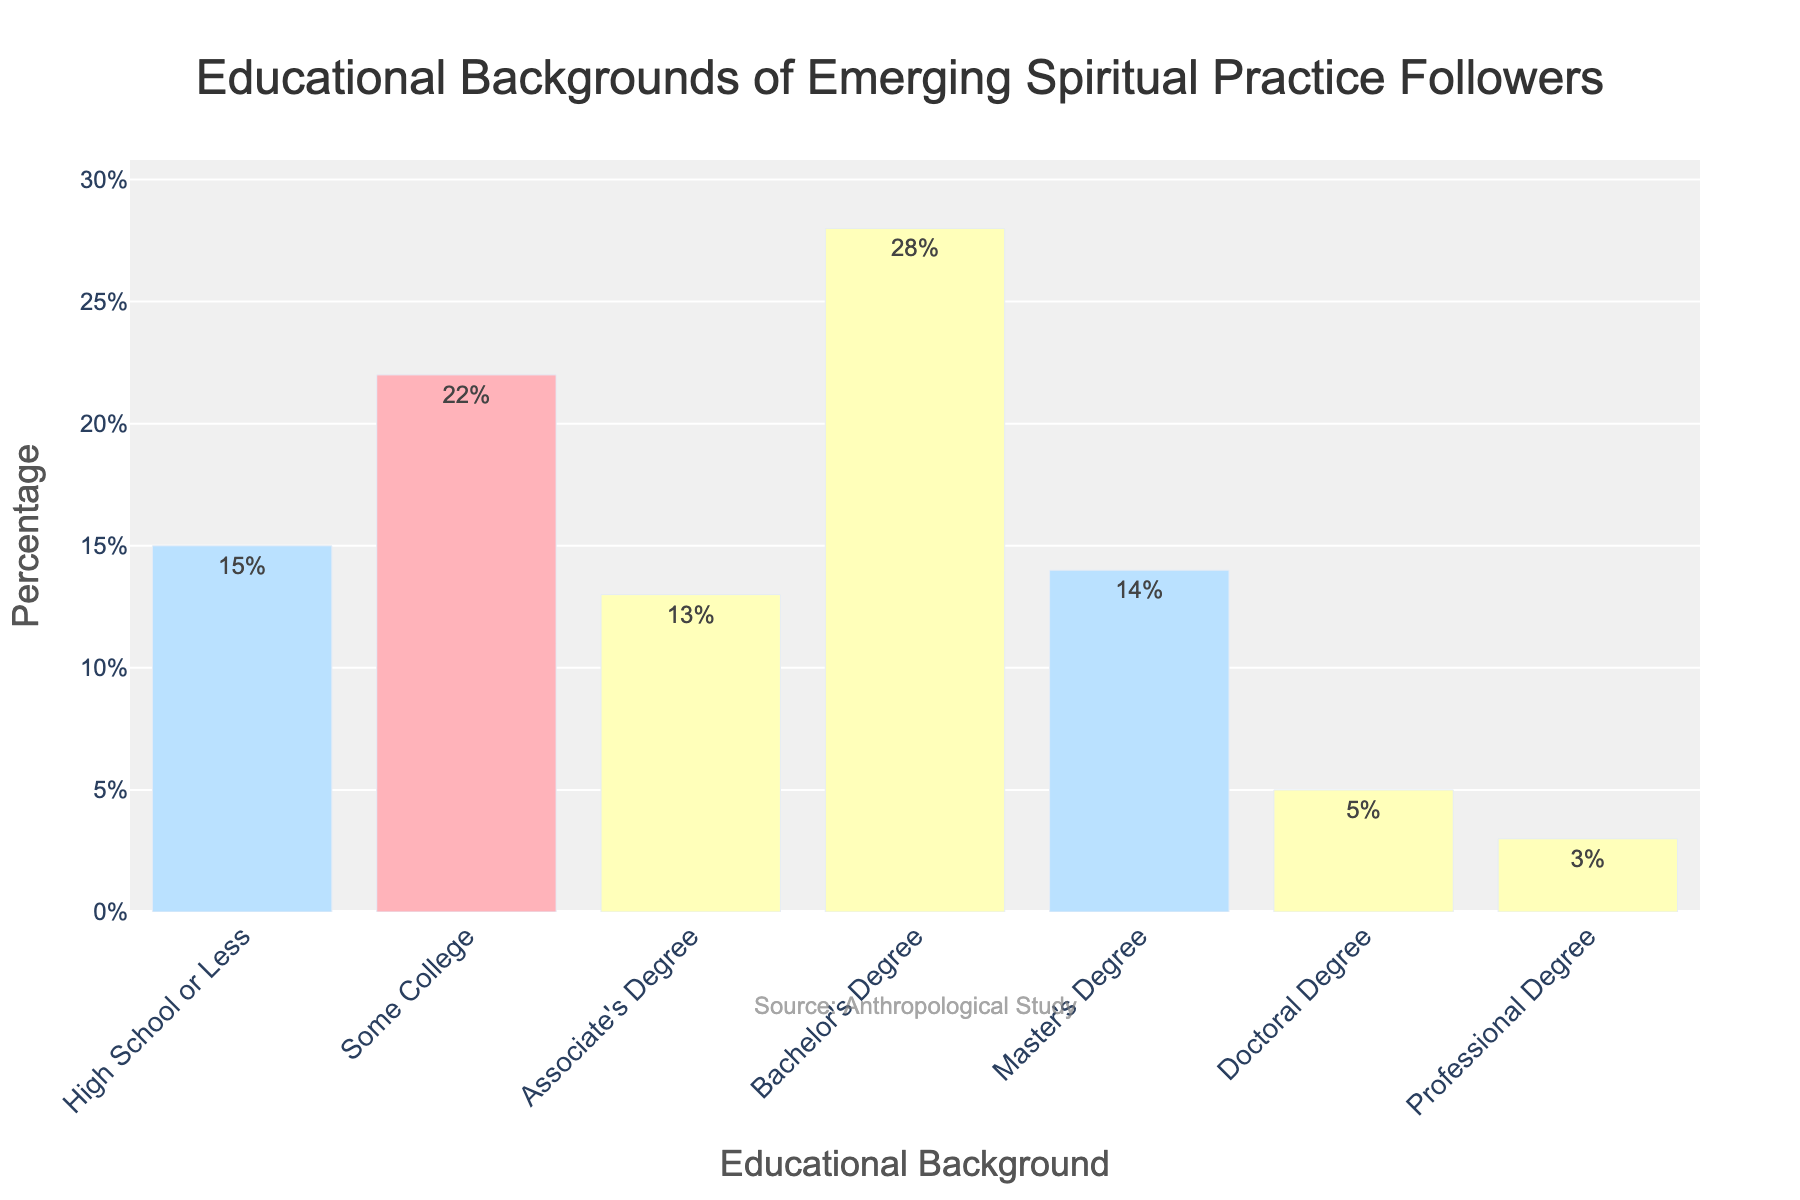Which educational background has the highest percentage among followers of emerging spiritual practices? To answer this question, look at the bar with the greatest height in the figure. This corresponds to the 'Bachelor's Degree' category.
Answer: Bachelor's Degree Which educational background has the lowest percentage among followers of emerging spiritual practices? Look for the shortest bar in the figure. This is the 'Professional Degree' category.
Answer: Professional Degree How does the percentage of followers with a Master's Degree compare to those with a Doctoral Degree? To compare the two, observe the heights of the bars for 'Master's Degree' and 'Doctoral Degree'. The 'Master's Degree' bar is taller.
Answer: Master's Degree is higher What is the total percentage of followers with some form of college education (Some College, Associate's Degree, Bachelor's Degree, Master's Degree, or Doctoral Degree)? To find this total, add the percentages for all college-related categories: 22% (Some College) + 13% (Associate's Degree) + 28% (Bachelor's Degree) + 14% (Master's Degree) + 5% (Doctoral Degree). The sum is 82%.
Answer: 82% Which two educational backgrounds combined account for roughly half of the followers? To determine this, identify bars whose summed percentages are close to 50%. 'Some College' and 'Bachelor's Degree' offer a combined total of 22% + 28% = 50%.
Answer: Some College and Bachelor's Degree What is the difference in percentage between followers with a Bachelor's Degree and those with High School or Less? To find this difference, subtract the percentage for 'High School or Less' from 'Bachelor's Degree'. 28% (Bachelor's Degree) - 15% (High School or Less) = 13%.
Answer: 13% What percentage of followers have either an Associate's Degree or a Master's Degree? Add the percentages for 'Associate's Degree' and 'Master's Degree': 13% + 14% = 27%.
Answer: 27% Which educational background categories have a greater than 20% following? Identify the bars with percentages above 20%. These are 'Some College' (22%) and 'Bachelor's Degree' (28%).
Answer: Some College and Bachelor's Degree Is the total percentage of followers with either a Doctoral Degree or a Professional Degree greater than the percentage of those with an Associate's Degree? Add the percentages for 'Doctoral Degree' and 'Professional Degree' and compare to 'Associate's Degree'. 5% + 3% = 8%, which is less than 13%.
Answer: No How close is the percentage of followers with a Master's Degree to the percentage of those with an Associate's Degree? Subtract 'Associate's Degree' from 'Master's Degree': 14% - 13% = 1%.
Answer: 1% 